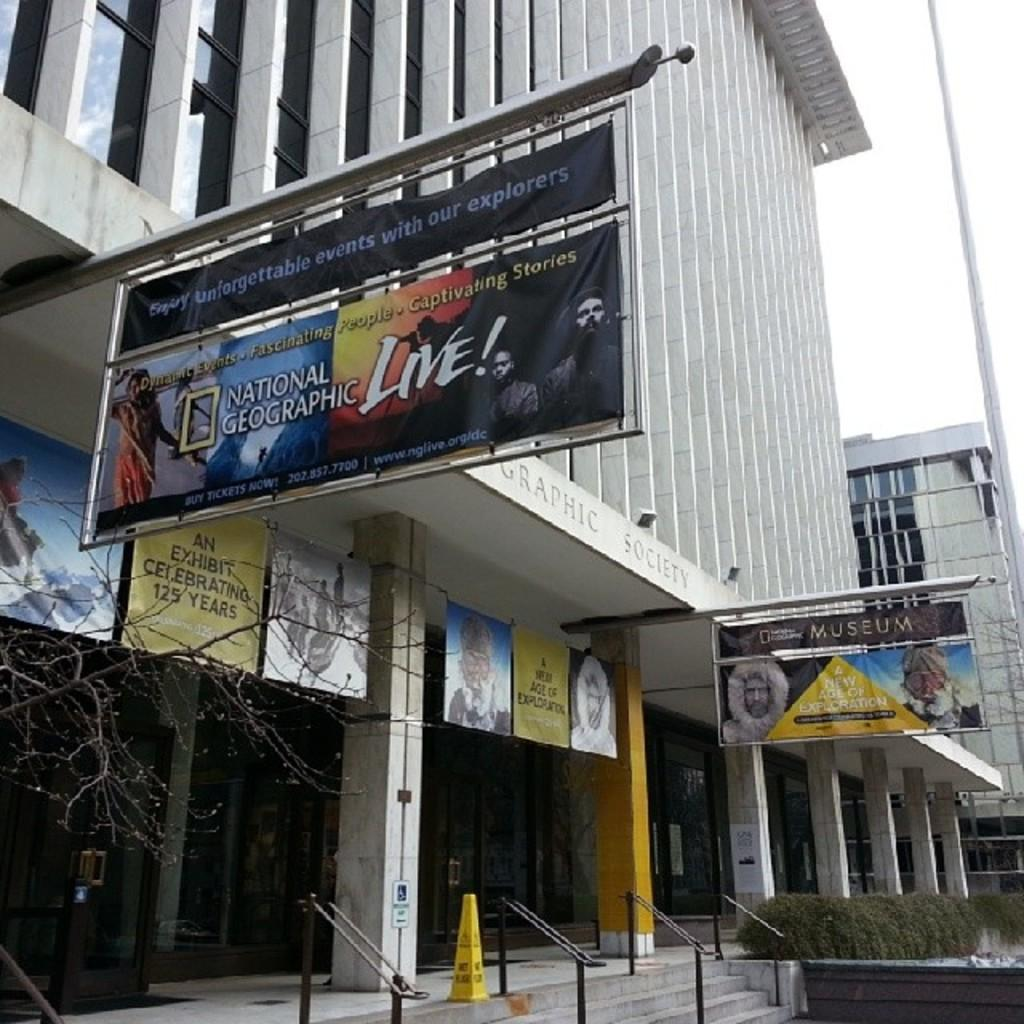<image>
Write a terse but informative summary of the picture. A banner for National Geographic live hangs out over the sidewalk. 